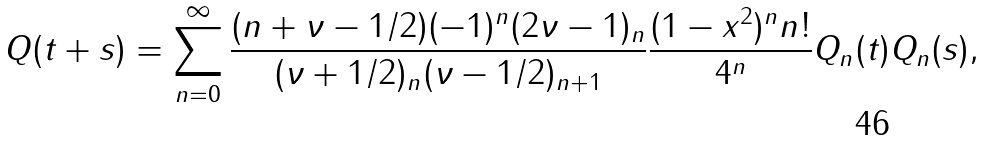Convert formula to latex. <formula><loc_0><loc_0><loc_500><loc_500>Q ( t + s ) = \sum _ { n = 0 } ^ { \infty } \frac { ( n + \nu - 1 / 2 ) ( - 1 ) ^ { n } ( 2 \nu - 1 ) _ { n } } { ( \nu + 1 / 2 ) _ { n } ( \nu - 1 / 2 ) _ { n + 1 } } \frac { ( 1 - x ^ { 2 } ) ^ { n } n ! } { 4 ^ { n } } Q _ { n } ( t ) Q _ { n } ( s ) ,</formula> 